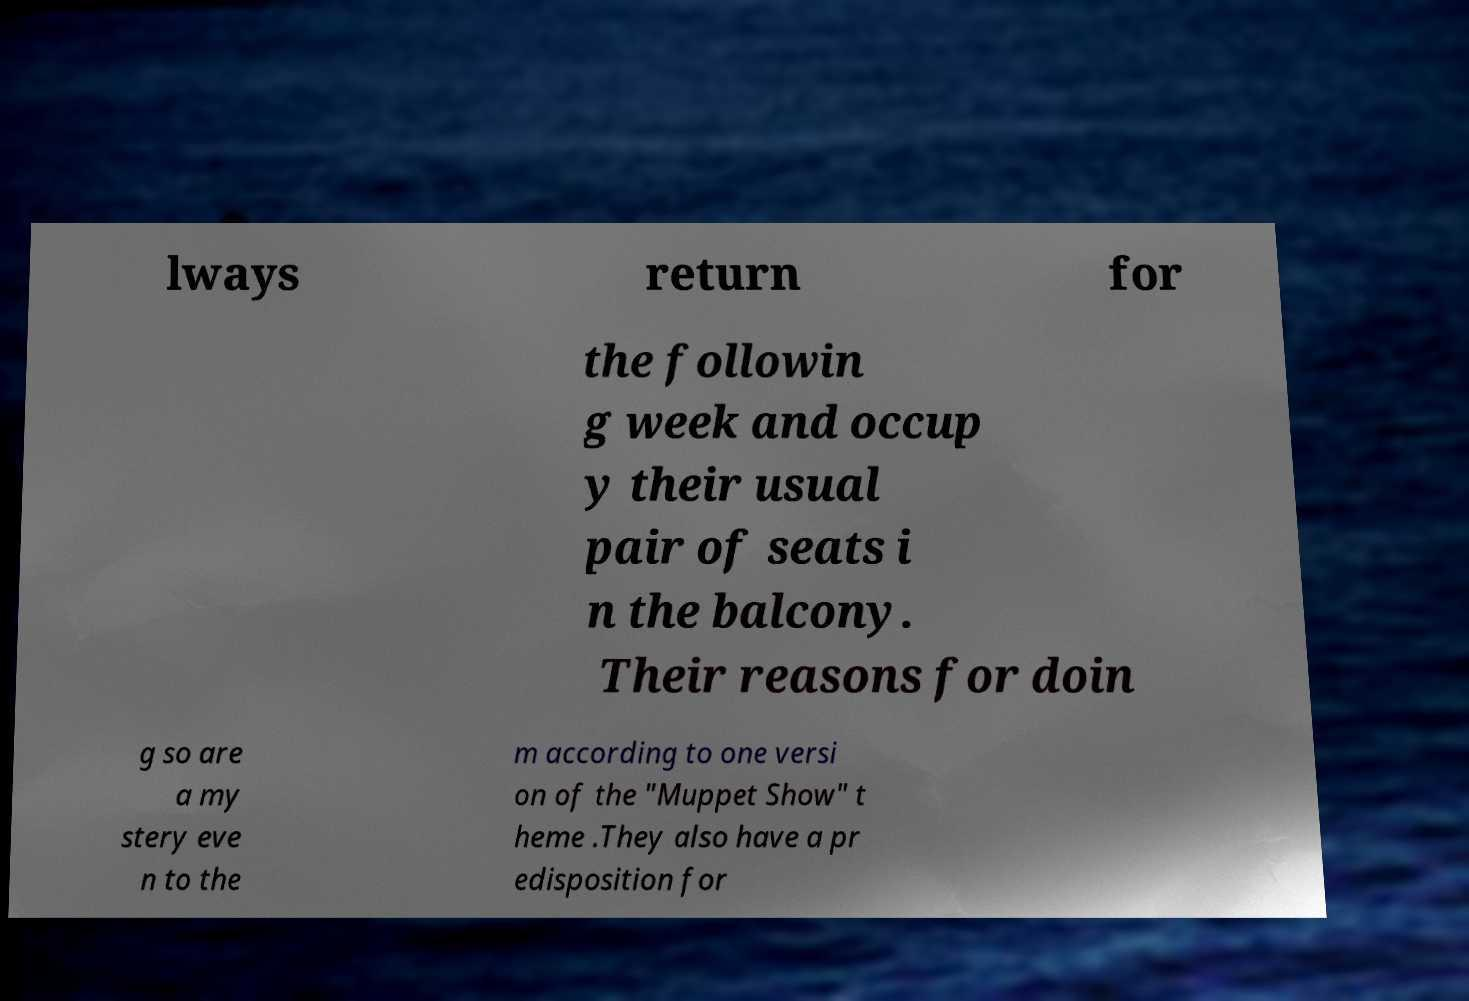Please read and relay the text visible in this image. What does it say? lways return for the followin g week and occup y their usual pair of seats i n the balcony. Their reasons for doin g so are a my stery eve n to the m according to one versi on of the "Muppet Show" t heme .They also have a pr edisposition for 